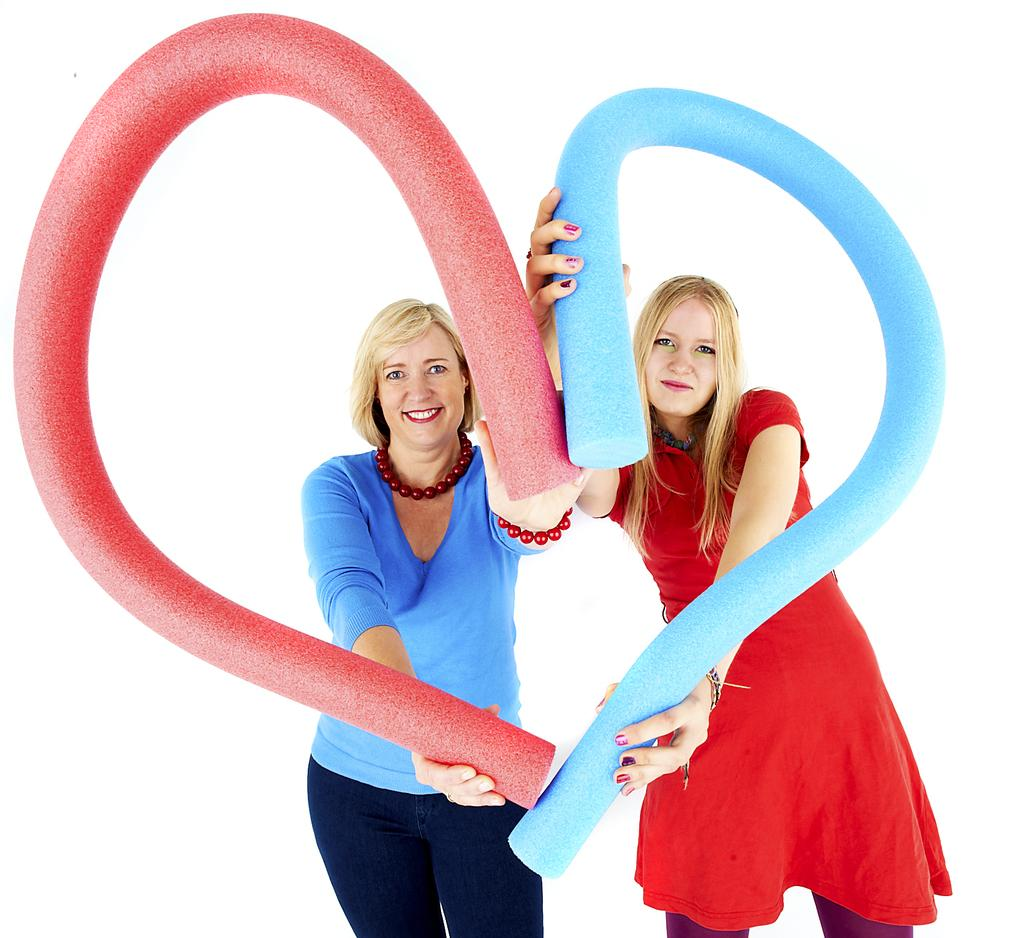How many people are in the image? There are two women in the image. What are the women doing in the image? The women are standing in the image. What are the women holding in the image? The women are holding objects in the image. What is the color of the background in the image? The background of the image is white. What type of gold jewelry is the carpenter wearing in the image? There is no carpenter or gold jewelry present in the image. 